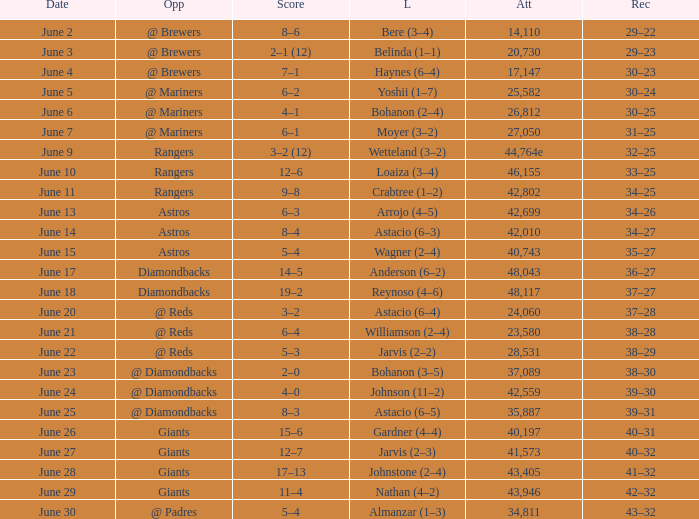What's the record when the attendance was 28,531? 38–29. 